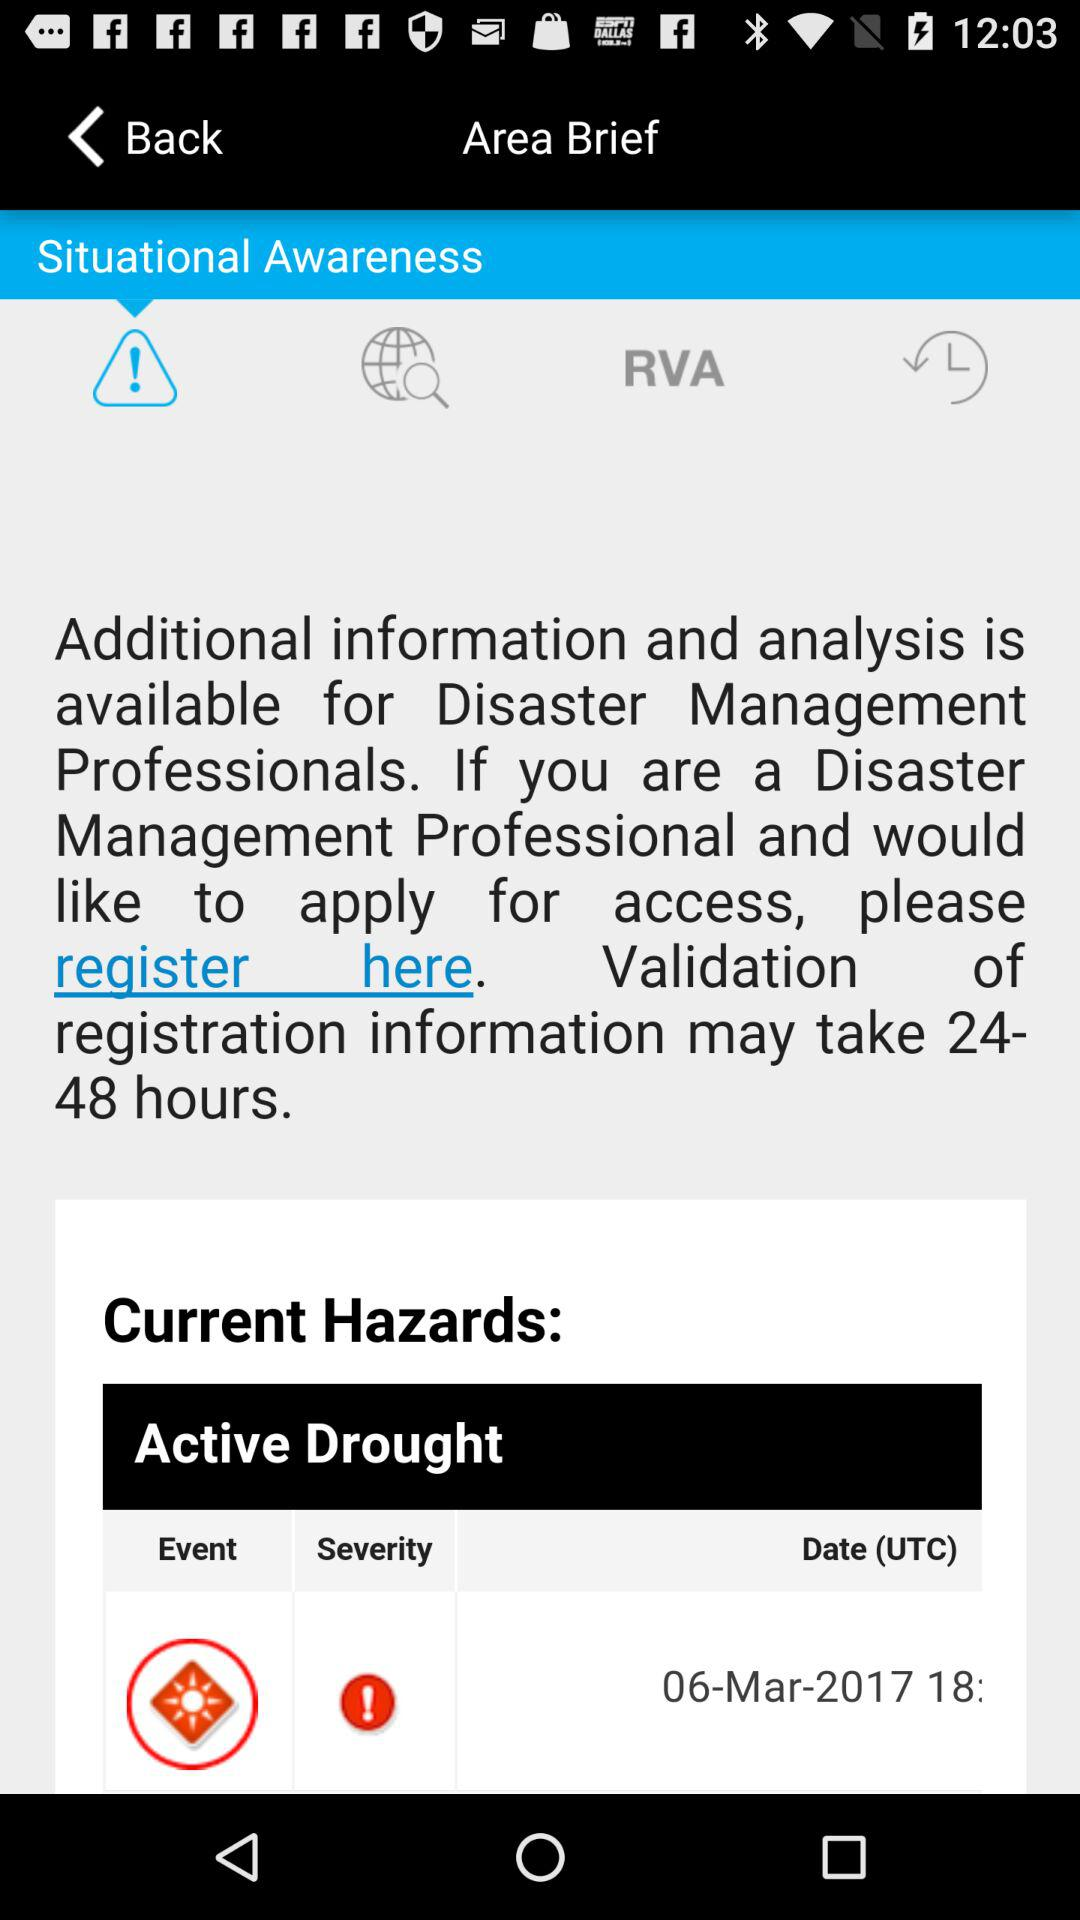What are the current hazards? The current hazard is an active drought. 